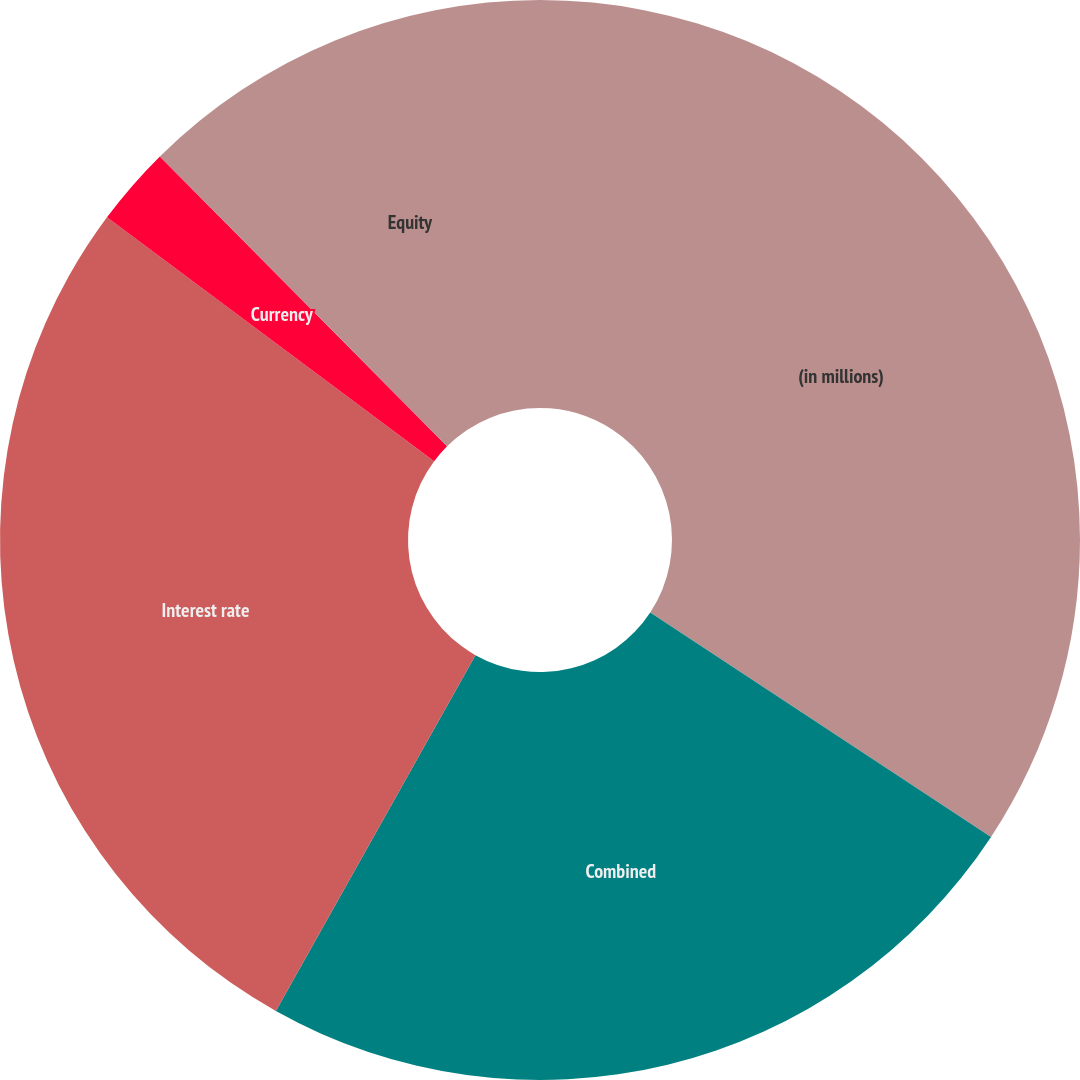<chart> <loc_0><loc_0><loc_500><loc_500><pie_chart><fcel>(in millions)<fcel>Combined<fcel>Interest rate<fcel>Currency<fcel>Equity<nl><fcel>34.27%<fcel>23.87%<fcel>27.06%<fcel>2.38%<fcel>12.43%<nl></chart> 